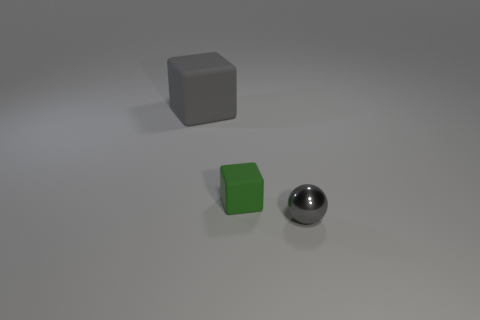Add 2 gray objects. How many objects exist? 5 Subtract all balls. How many objects are left? 2 Subtract 0 red cylinders. How many objects are left? 3 Subtract all large green shiny cubes. Subtract all metallic balls. How many objects are left? 2 Add 3 rubber objects. How many rubber objects are left? 5 Add 2 objects. How many objects exist? 5 